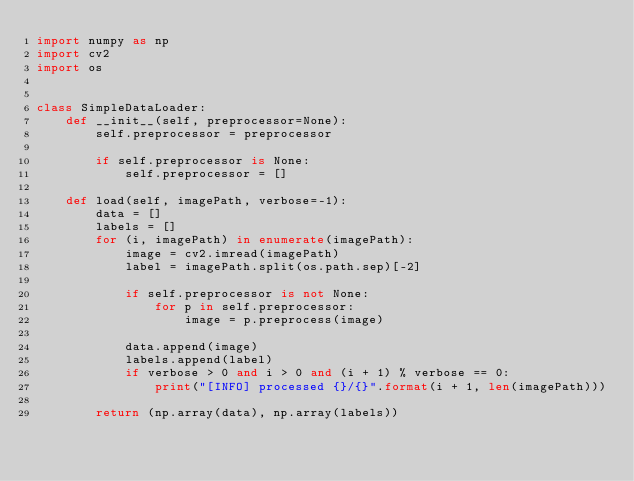<code> <loc_0><loc_0><loc_500><loc_500><_Python_>import numpy as np
import cv2
import os


class SimpleDataLoader:
    def __init__(self, preprocessor=None):
        self.preprocessor = preprocessor

        if self.preprocessor is None:
            self.preprocessor = []

    def load(self, imagePath, verbose=-1):
        data = []
        labels = []
        for (i, imagePath) in enumerate(imagePath):
            image = cv2.imread(imagePath)
            label = imagePath.split(os.path.sep)[-2]

            if self.preprocessor is not None:
                for p in self.preprocessor:
                    image = p.preprocess(image)

            data.append(image)
            labels.append(label)
            if verbose > 0 and i > 0 and (i + 1) % verbose == 0:
                print("[INFO] processed {}/{}".format(i + 1, len(imagePath)))

        return (np.array(data), np.array(labels))
</code> 